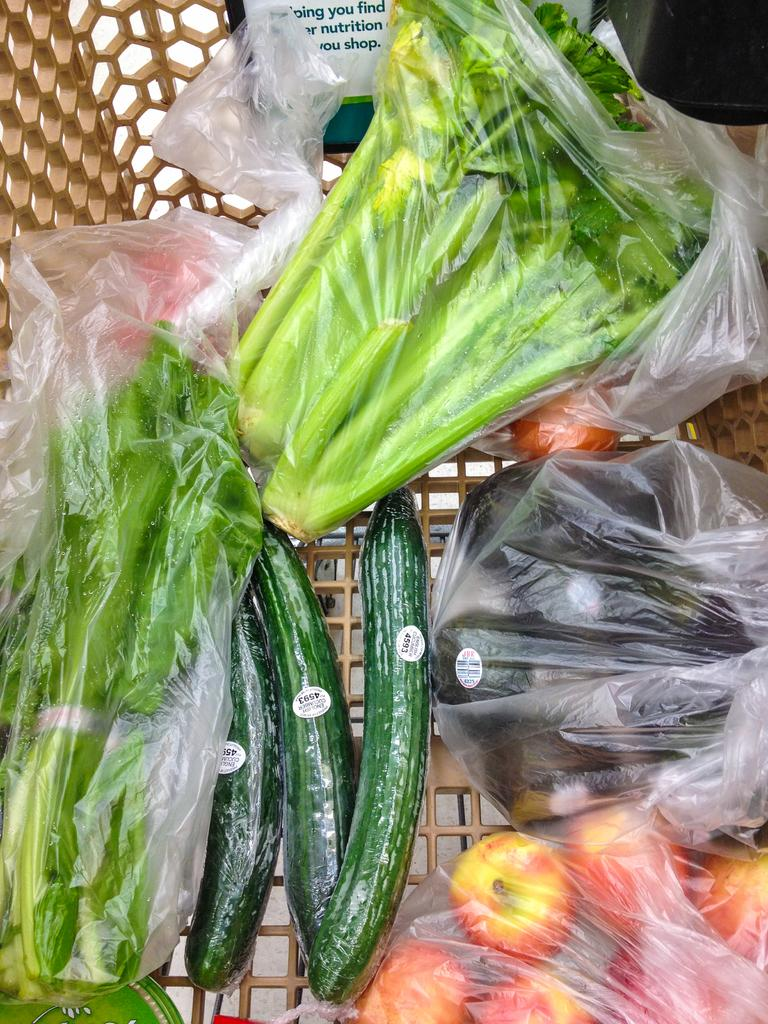What type of vegetables are wrapped in a cover in the image? There are vegetables wrapped in a cover in the image, but the specific type is not mentioned. What other vegetables can be seen in the image? There are tomatoes and cucumbers in the image. How are the vegetables arranged or contained in the image? The vegetables are in a basket. Can you hear the vegetables laughing in the image? There is no indication of laughter or sound in the image, as it is a still photograph of vegetables. 